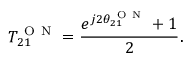Convert formula to latex. <formula><loc_0><loc_0><loc_500><loc_500>T _ { 2 1 } ^ { O N } = \frac { e ^ { j 2 \theta _ { 2 1 } ^ { O N } } + 1 } { 2 } .</formula> 